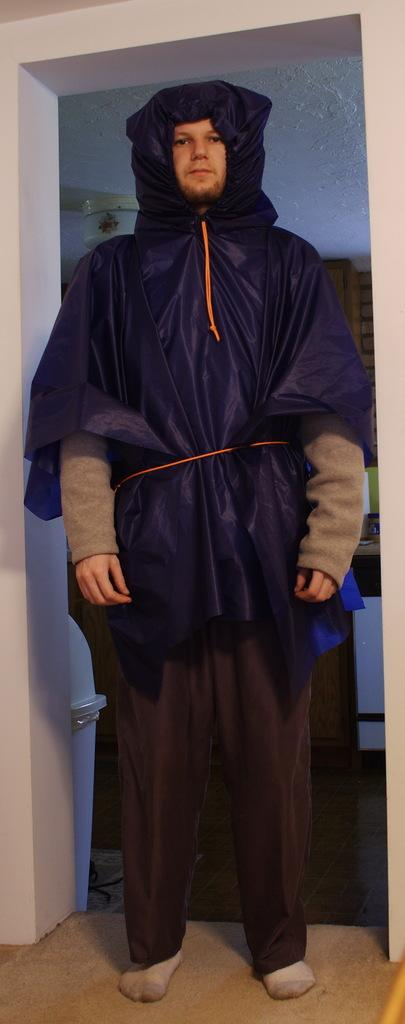Who is the main subject in the image? There is a man in the image. Where is the man positioned in the image? The man is standing in the front. What is the man wearing in the image? The man is wearing a black raincoat. What is the man doing in the image? The man is giving a pose to the camera. What can be seen in the background of the image? There is a white arch wall in the background of the image. What type of haircut does the man have in the image? The provided facts do not mention the man's haircut, so we cannot determine it from the image. What question is the man asking in the image? The provided facts do not mention the man asking any question in the image. 